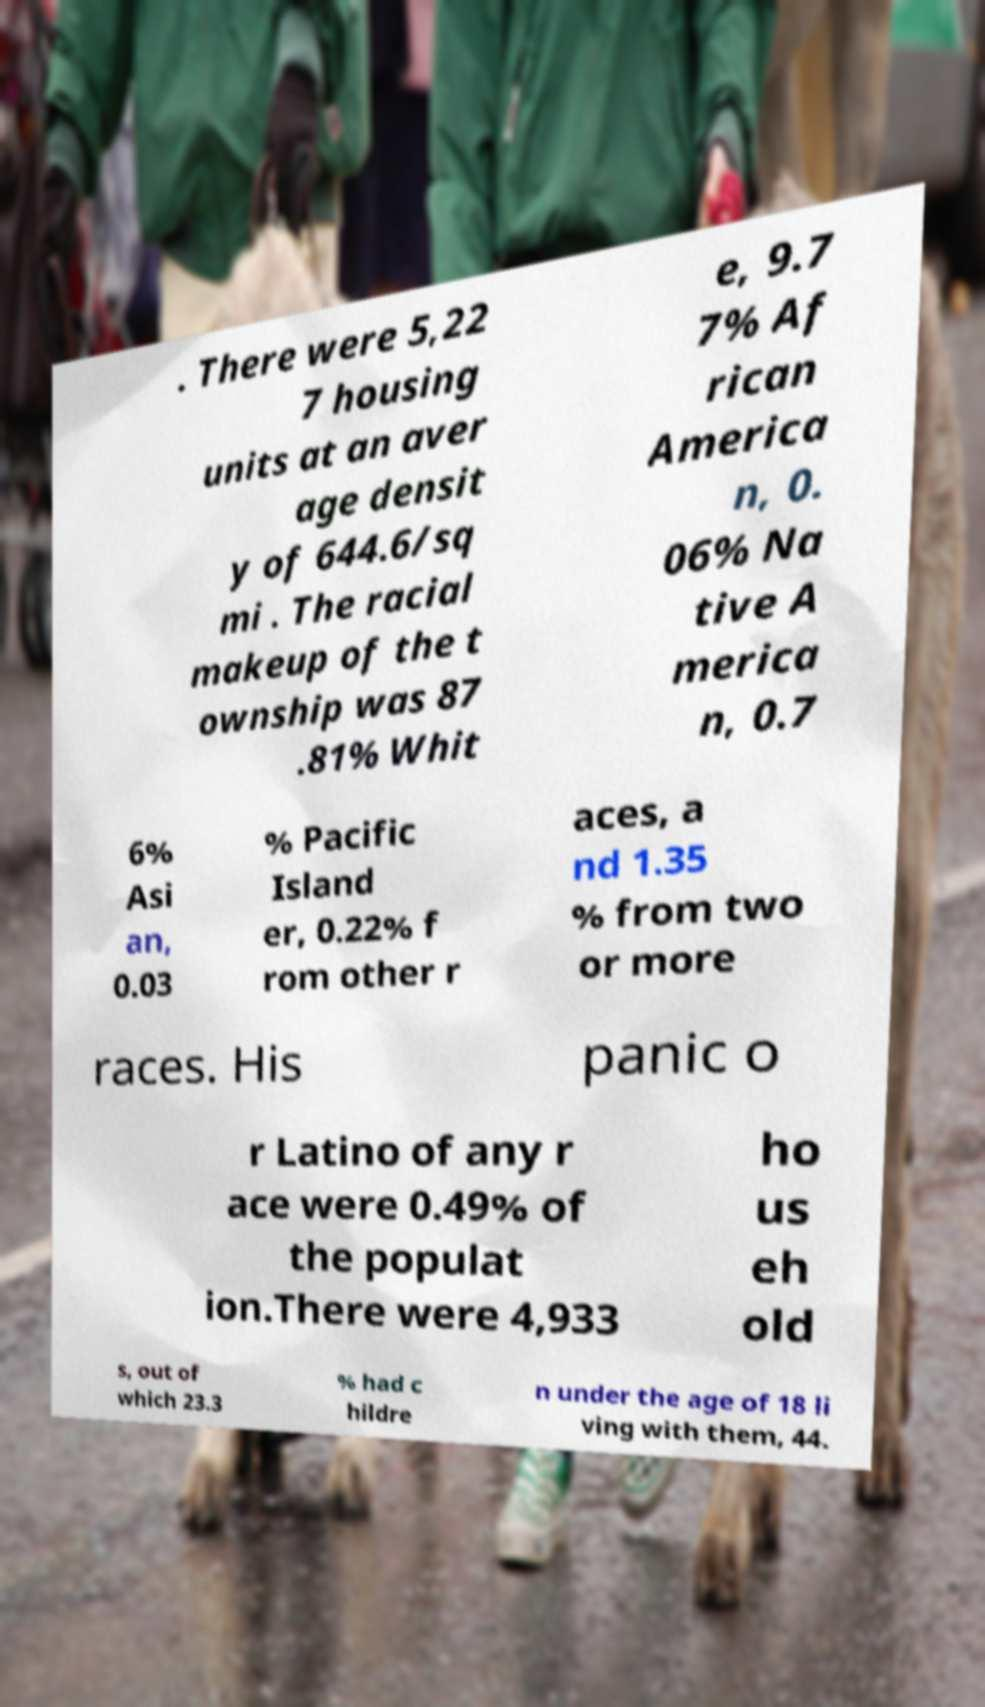Could you extract and type out the text from this image? . There were 5,22 7 housing units at an aver age densit y of 644.6/sq mi . The racial makeup of the t ownship was 87 .81% Whit e, 9.7 7% Af rican America n, 0. 06% Na tive A merica n, 0.7 6% Asi an, 0.03 % Pacific Island er, 0.22% f rom other r aces, a nd 1.35 % from two or more races. His panic o r Latino of any r ace were 0.49% of the populat ion.There were 4,933 ho us eh old s, out of which 23.3 % had c hildre n under the age of 18 li ving with them, 44. 